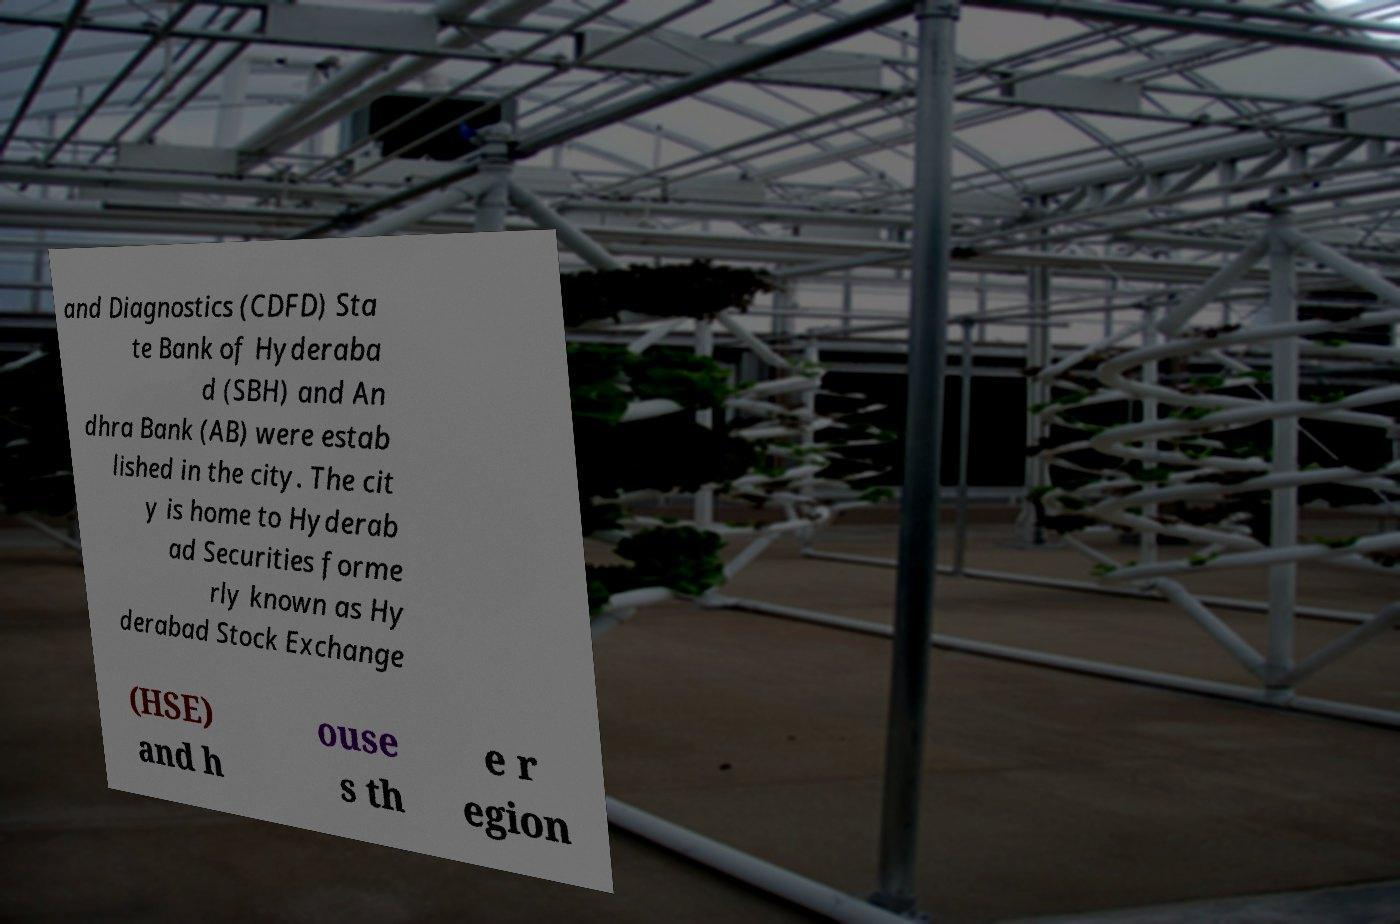Could you assist in decoding the text presented in this image and type it out clearly? and Diagnostics (CDFD) Sta te Bank of Hyderaba d (SBH) and An dhra Bank (AB) were estab lished in the city. The cit y is home to Hyderab ad Securities forme rly known as Hy derabad Stock Exchange (HSE) and h ouse s th e r egion 